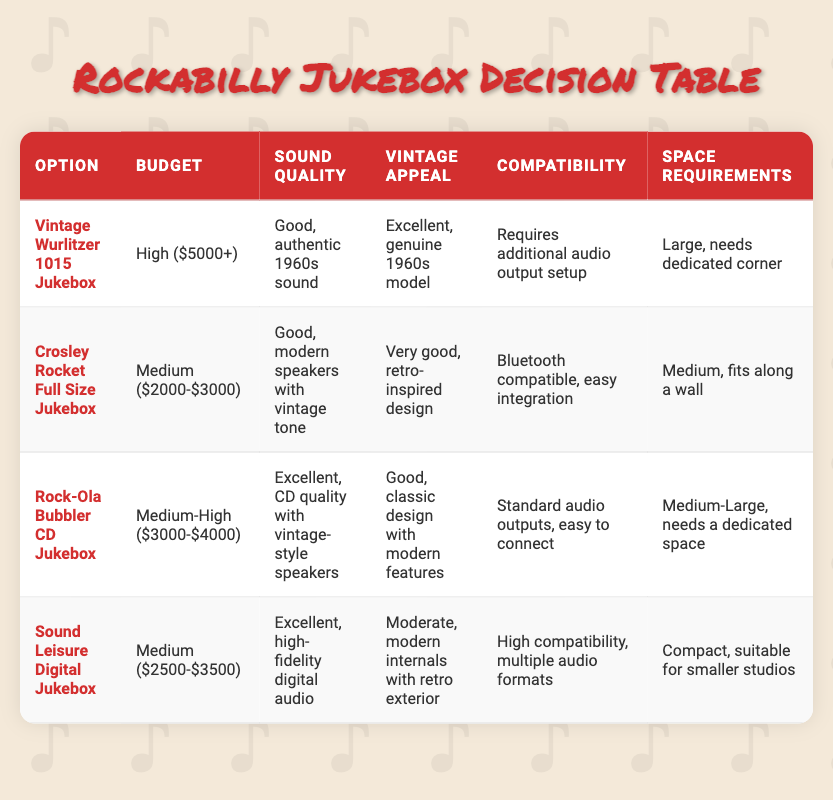What is the budget range for the Vintage Wurlitzer 1015 Jukebox? The table states that the budget for the Vintage Wurlitzer 1015 Jukebox is categorized as "High ($5000+)".
Answer: High ($5000+) What is the sound quality of the Sound Leisure Digital Jukebox? According to the table, the sound quality of the Sound Leisure Digital Jukebox is described as "Excellent, high-fidelity digital audio".
Answer: Excellent, high-fidelity digital audio Does the Crosley Rocket Full Size Jukebox have Bluetooth compatibility? The table indicates that the Crosley Rocket Full Size Jukebox is "Bluetooth compatible, easy integration", which confirms it does have Bluetooth compatibility.
Answer: Yes Which jukebox has the best vintage appeal? The table shows that the Vintage Wurlitzer 1015 Jukebox has an "Excellent, genuine 1960s model" vintage appeal, which is the top rating among all options listed.
Answer: Vintage Wurlitzer 1015 Jukebox What is the average budget range of all options listed? The budget ranges from "High ($5000+)", "Medium ($2000-$3000)", "Medium-High ($3000-$4000)", and "Medium ($2500-$3500)". After analysis, in terms of thresholds, we can consider: High as 5000+, Medium as 2500-3000, Medium-High as 3000-4000. The average budget can be approximated as (5000 + 3000 + 2500 + 4000)/4 = 3625. Therefore, the average budget falls between the ranges given, which we can categorize as "Medium-High ($3000-$4000)".
Answer: Medium-High ($3000-$4000) Which jukebox requires additional audio output setup? The table specifies that the Vintage Wurlitzer 1015 Jukebox "Requires additional audio output setup". No other options mention this requirement.
Answer: Vintage Wurlitzer 1015 Jukebox What is the space requirement for the Rock-Ola Bubbler CD Jukebox? The table lists the space requirements for the Rock-Ola Bubbler CD Jukebox as "Medium-Large, needs a dedicated space."
Answer: Medium-Large, needs a dedicated space Is the Sound Leisure Digital Jukebox the most compact option available? The Sound Leisure Digital Jukebox is classified as "Compact, suitable for smaller studios" in the space requirements. By comparing it to other options, the Vintage Wurlitzer and Rock-Ola have larger space requirements, confirming that the Sound Leisure is indeed the most compact.
Answer: Yes Which options have a "Good" sound quality? The table reveals that both the Vintage Wurlitzer 1015 and the Crosley Rocket have a "Good" sound quality rating. First, we locate the sound quality of each option and filter those listed as "Good".
Answer: Vintage Wurlitzer 1015 Jukebox, Crosley Rocket Full Size Jukebox 